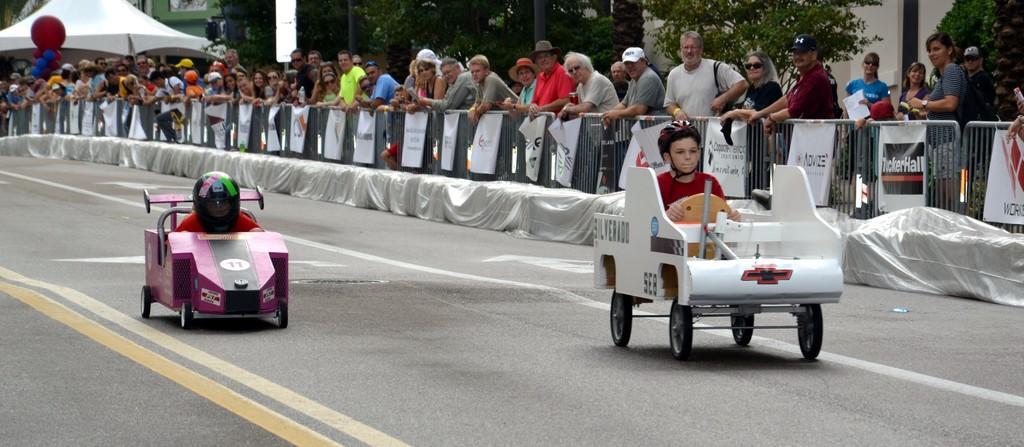Describe this image in one or two sentences. In this image, there are two persons riding the vehicles on the road. There are banners hanging to the barricades and I can see groups of people standing. At the top left corner of the image, I can see a canopy tent and an object. In the background, there are trees and buildings. 